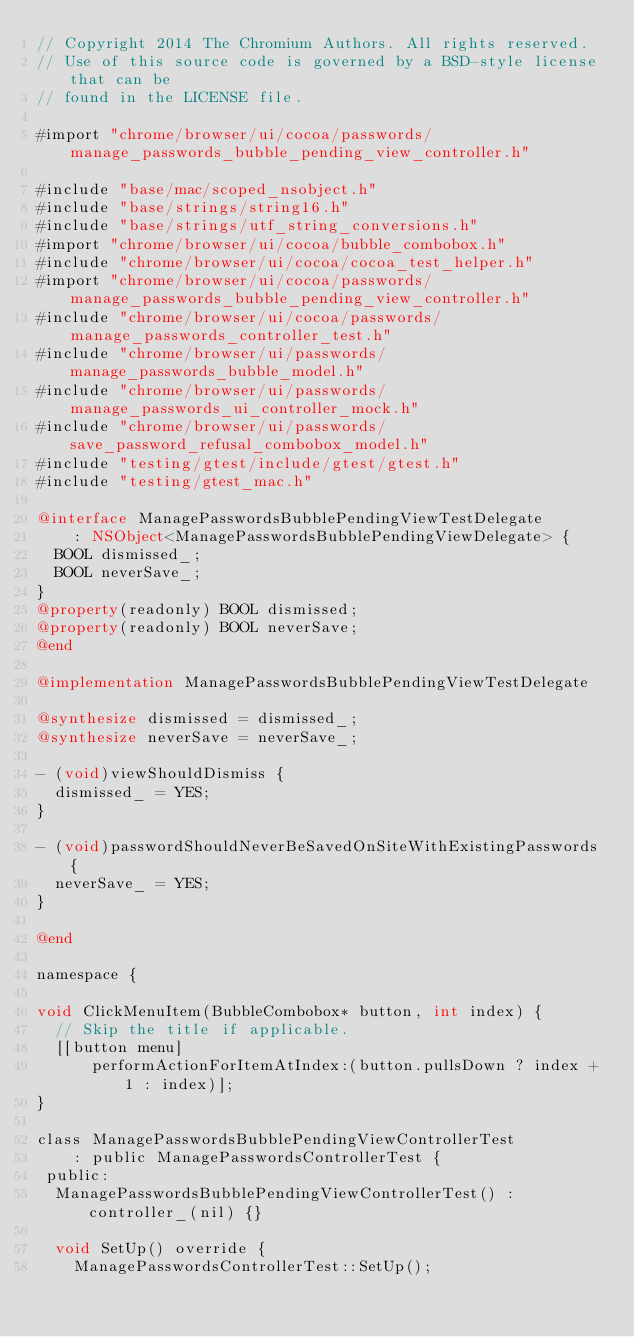Convert code to text. <code><loc_0><loc_0><loc_500><loc_500><_ObjectiveC_>// Copyright 2014 The Chromium Authors. All rights reserved.
// Use of this source code is governed by a BSD-style license that can be
// found in the LICENSE file.

#import "chrome/browser/ui/cocoa/passwords/manage_passwords_bubble_pending_view_controller.h"

#include "base/mac/scoped_nsobject.h"
#include "base/strings/string16.h"
#include "base/strings/utf_string_conversions.h"
#import "chrome/browser/ui/cocoa/bubble_combobox.h"
#include "chrome/browser/ui/cocoa/cocoa_test_helper.h"
#import "chrome/browser/ui/cocoa/passwords/manage_passwords_bubble_pending_view_controller.h"
#include "chrome/browser/ui/cocoa/passwords/manage_passwords_controller_test.h"
#include "chrome/browser/ui/passwords/manage_passwords_bubble_model.h"
#include "chrome/browser/ui/passwords/manage_passwords_ui_controller_mock.h"
#include "chrome/browser/ui/passwords/save_password_refusal_combobox_model.h"
#include "testing/gtest/include/gtest/gtest.h"
#include "testing/gtest_mac.h"

@interface ManagePasswordsBubblePendingViewTestDelegate
    : NSObject<ManagePasswordsBubblePendingViewDelegate> {
  BOOL dismissed_;
  BOOL neverSave_;
}
@property(readonly) BOOL dismissed;
@property(readonly) BOOL neverSave;
@end

@implementation ManagePasswordsBubblePendingViewTestDelegate

@synthesize dismissed = dismissed_;
@synthesize neverSave = neverSave_;

- (void)viewShouldDismiss {
  dismissed_ = YES;
}

- (void)passwordShouldNeverBeSavedOnSiteWithExistingPasswords {
  neverSave_ = YES;
}

@end

namespace {

void ClickMenuItem(BubbleCombobox* button, int index) {
  // Skip the title if applicable.
  [[button menu]
      performActionForItemAtIndex:(button.pullsDown ? index + 1 : index)];
}

class ManagePasswordsBubblePendingViewControllerTest
    : public ManagePasswordsControllerTest {
 public:
  ManagePasswordsBubblePendingViewControllerTest() : controller_(nil) {}

  void SetUp() override {
    ManagePasswordsControllerTest::SetUp();</code> 